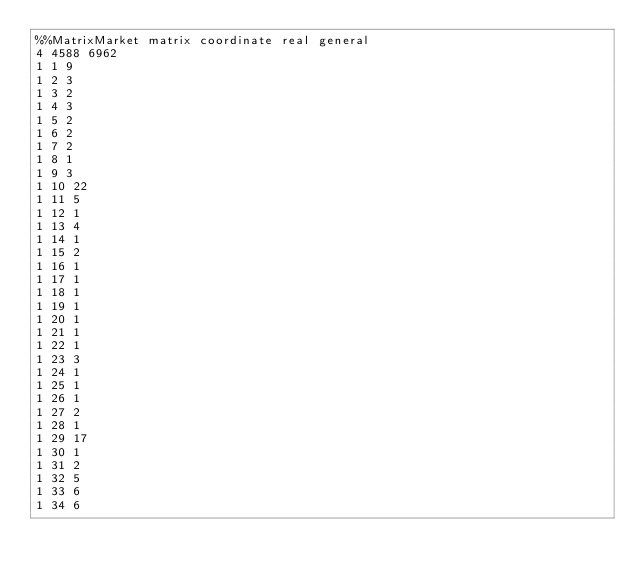<code> <loc_0><loc_0><loc_500><loc_500><_ObjectiveC_>%%MatrixMarket matrix coordinate real general
4 4588 6962                                       
1 1 9
1 2 3
1 3 2
1 4 3
1 5 2
1 6 2
1 7 2
1 8 1
1 9 3
1 10 22
1 11 5
1 12 1
1 13 4
1 14 1
1 15 2
1 16 1
1 17 1
1 18 1
1 19 1
1 20 1
1 21 1
1 22 1
1 23 3
1 24 1
1 25 1
1 26 1
1 27 2
1 28 1
1 29 17
1 30 1
1 31 2
1 32 5
1 33 6
1 34 6</code> 